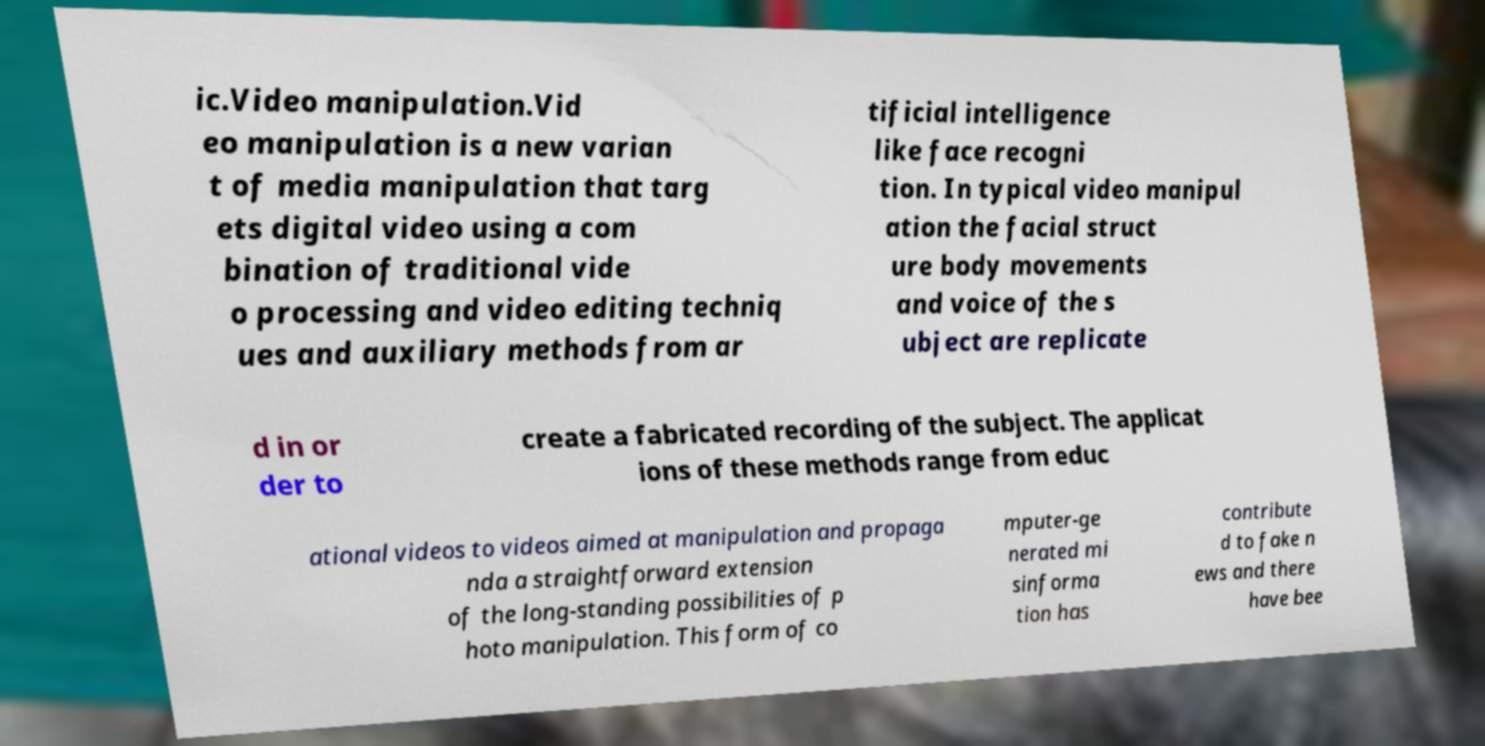Can you read and provide the text displayed in the image?This photo seems to have some interesting text. Can you extract and type it out for me? ic.Video manipulation.Vid eo manipulation is a new varian t of media manipulation that targ ets digital video using a com bination of traditional vide o processing and video editing techniq ues and auxiliary methods from ar tificial intelligence like face recogni tion. In typical video manipul ation the facial struct ure body movements and voice of the s ubject are replicate d in or der to create a fabricated recording of the subject. The applicat ions of these methods range from educ ational videos to videos aimed at manipulation and propaga nda a straightforward extension of the long-standing possibilities of p hoto manipulation. This form of co mputer-ge nerated mi sinforma tion has contribute d to fake n ews and there have bee 